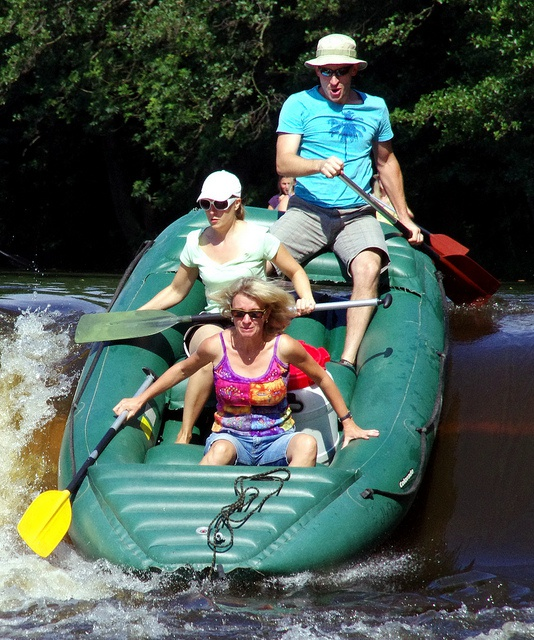Describe the objects in this image and their specific colors. I can see boat in black, teal, and ivory tones, people in black, ivory, and cyan tones, people in black, tan, maroon, and ivory tones, people in black, ivory, gray, and tan tones, and people in black, tan, ivory, and purple tones in this image. 